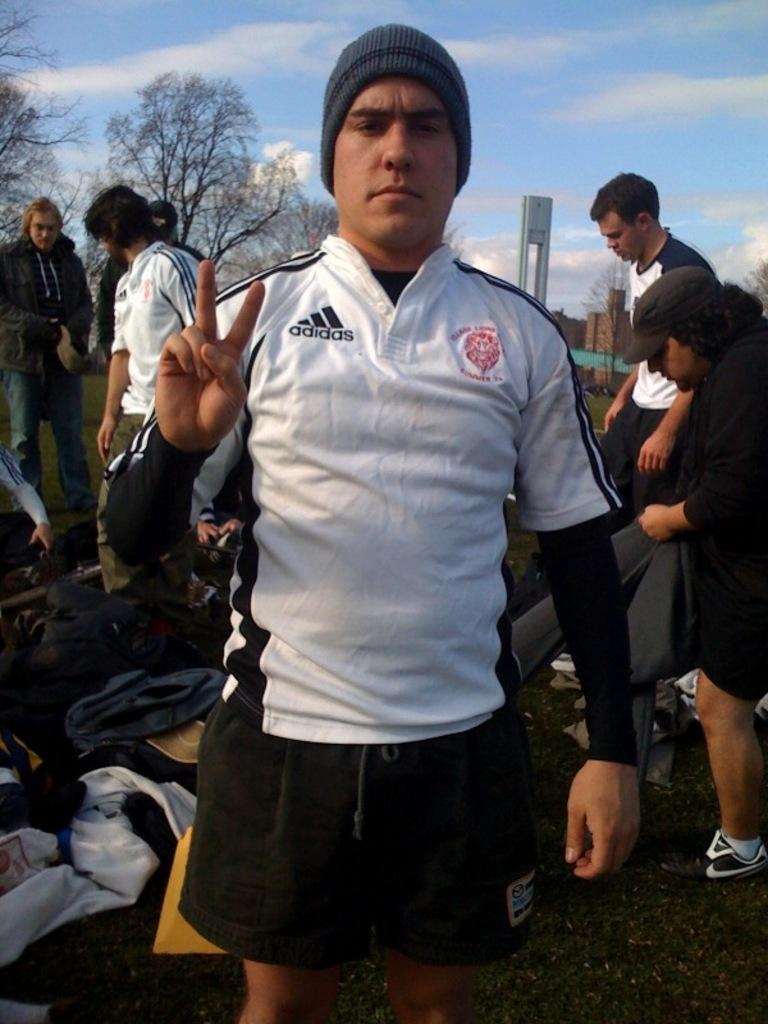<image>
Offer a succinct explanation of the picture presented. The man is wearing a white Adidas branded jersey but the other logo is unreadable. 